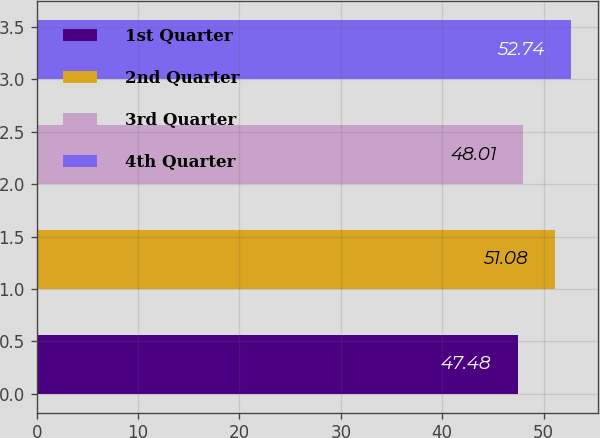<chart> <loc_0><loc_0><loc_500><loc_500><bar_chart><fcel>1st Quarter<fcel>2nd Quarter<fcel>3rd Quarter<fcel>4th Quarter<nl><fcel>47.48<fcel>51.08<fcel>48.01<fcel>52.74<nl></chart> 